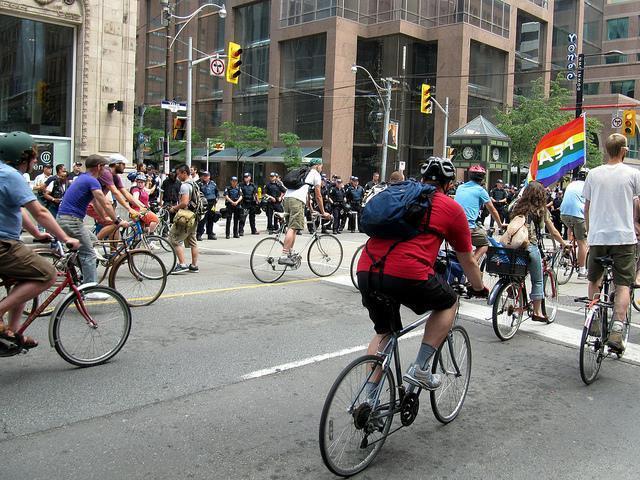How many people are there?
Give a very brief answer. 6. How many bicycles are there?
Give a very brief answer. 6. 